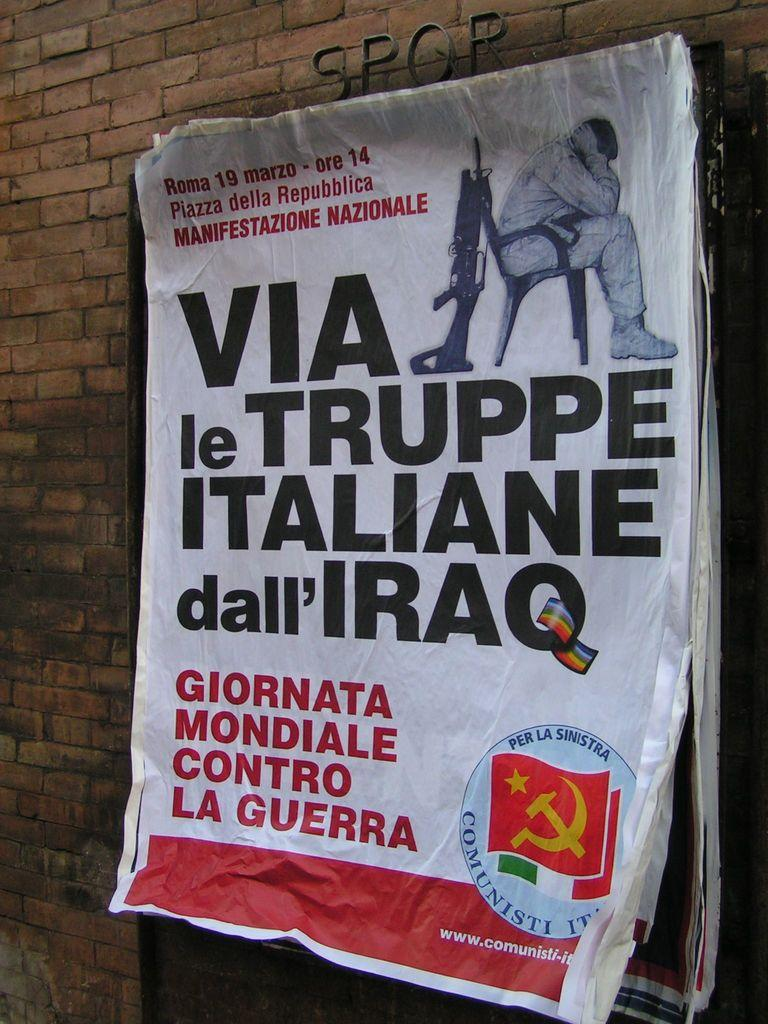<image>
Offer a succinct explanation of the picture presented. A poster with the words Via le Truppe Italiane dall' Iraq hangs on a brick wall. 